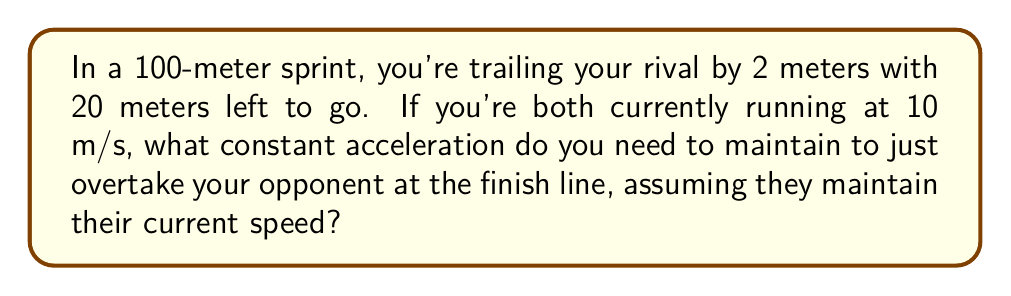What is the answer to this math problem? Let's approach this step-by-step:

1) First, we need to set up our equations of motion. We'll use:
   $$s = ut + \frac{1}{2}at^2$$
   where $s$ is displacement, $u$ is initial velocity, $a$ is acceleration, and $t$ is time.

2) For your rival:
   $$s_r = 20\text{ m}$$
   $$u_r = 10\text{ m/s}$$
   $$a_r = 0\text{ m/s}^2$$

3) For you:
   $$s_y = 22\text{ m}$$ (because you need to cover 2 m more)
   $$u_y = 10\text{ m/s}$$
   $$a_y = \text{unknown}$$

4) The time taken will be the same for both of you. For your rival:
   $$20 = 10t + \frac{1}{2}(0)t^2$$
   $$t = 2\text{ s}$$

5) Now we can set up the equation for your motion:
   $$22 = 10(2) + \frac{1}{2}a_y(2)^2$$

6) Simplify:
   $$22 = 20 + 2a_y$$

7) Solve for $a_y$:
   $$2a_y = 2$$
   $$a_y = 1\text{ m/s}^2$$

Therefore, you need to maintain an acceleration of 1 m/s² to just overtake your opponent at the finish line.
Answer: $1\text{ m/s}^2$ 